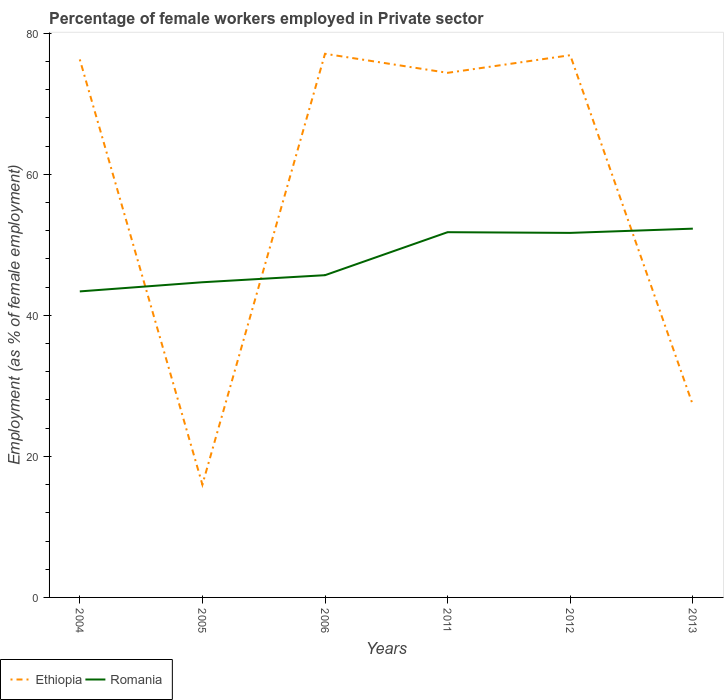Across all years, what is the maximum percentage of females employed in Private sector in Romania?
Your answer should be compact. 43.4. In which year was the percentage of females employed in Private sector in Romania maximum?
Provide a succinct answer. 2004. What is the total percentage of females employed in Private sector in Romania in the graph?
Your answer should be compact. 0.1. What is the difference between the highest and the second highest percentage of females employed in Private sector in Ethiopia?
Your answer should be very brief. 61.1. How many lines are there?
Make the answer very short. 2. What is the difference between two consecutive major ticks on the Y-axis?
Give a very brief answer. 20. What is the title of the graph?
Offer a terse response. Percentage of female workers employed in Private sector. What is the label or title of the X-axis?
Provide a short and direct response. Years. What is the label or title of the Y-axis?
Keep it short and to the point. Employment (as % of female employment). What is the Employment (as % of female employment) of Ethiopia in 2004?
Ensure brevity in your answer.  76.3. What is the Employment (as % of female employment) in Romania in 2004?
Keep it short and to the point. 43.4. What is the Employment (as % of female employment) in Ethiopia in 2005?
Offer a terse response. 16. What is the Employment (as % of female employment) of Romania in 2005?
Your answer should be compact. 44.7. What is the Employment (as % of female employment) in Ethiopia in 2006?
Make the answer very short. 77.1. What is the Employment (as % of female employment) in Romania in 2006?
Ensure brevity in your answer.  45.7. What is the Employment (as % of female employment) in Ethiopia in 2011?
Make the answer very short. 74.4. What is the Employment (as % of female employment) in Romania in 2011?
Provide a short and direct response. 51.8. What is the Employment (as % of female employment) in Ethiopia in 2012?
Ensure brevity in your answer.  76.9. What is the Employment (as % of female employment) in Romania in 2012?
Provide a succinct answer. 51.7. What is the Employment (as % of female employment) in Ethiopia in 2013?
Provide a short and direct response. 27.3. What is the Employment (as % of female employment) of Romania in 2013?
Offer a terse response. 52.3. Across all years, what is the maximum Employment (as % of female employment) of Ethiopia?
Your answer should be compact. 77.1. Across all years, what is the maximum Employment (as % of female employment) of Romania?
Your response must be concise. 52.3. Across all years, what is the minimum Employment (as % of female employment) in Ethiopia?
Give a very brief answer. 16. Across all years, what is the minimum Employment (as % of female employment) in Romania?
Your answer should be compact. 43.4. What is the total Employment (as % of female employment) of Ethiopia in the graph?
Provide a succinct answer. 348. What is the total Employment (as % of female employment) in Romania in the graph?
Your response must be concise. 289.6. What is the difference between the Employment (as % of female employment) in Ethiopia in 2004 and that in 2005?
Your answer should be very brief. 60.3. What is the difference between the Employment (as % of female employment) of Romania in 2004 and that in 2005?
Provide a short and direct response. -1.3. What is the difference between the Employment (as % of female employment) of Ethiopia in 2004 and that in 2006?
Ensure brevity in your answer.  -0.8. What is the difference between the Employment (as % of female employment) of Romania in 2004 and that in 2011?
Keep it short and to the point. -8.4. What is the difference between the Employment (as % of female employment) of Ethiopia in 2004 and that in 2013?
Offer a very short reply. 49. What is the difference between the Employment (as % of female employment) in Romania in 2004 and that in 2013?
Your response must be concise. -8.9. What is the difference between the Employment (as % of female employment) in Ethiopia in 2005 and that in 2006?
Your response must be concise. -61.1. What is the difference between the Employment (as % of female employment) of Romania in 2005 and that in 2006?
Ensure brevity in your answer.  -1. What is the difference between the Employment (as % of female employment) of Ethiopia in 2005 and that in 2011?
Provide a succinct answer. -58.4. What is the difference between the Employment (as % of female employment) of Ethiopia in 2005 and that in 2012?
Ensure brevity in your answer.  -60.9. What is the difference between the Employment (as % of female employment) of Romania in 2005 and that in 2013?
Ensure brevity in your answer.  -7.6. What is the difference between the Employment (as % of female employment) in Ethiopia in 2006 and that in 2011?
Provide a succinct answer. 2.7. What is the difference between the Employment (as % of female employment) in Romania in 2006 and that in 2011?
Make the answer very short. -6.1. What is the difference between the Employment (as % of female employment) of Romania in 2006 and that in 2012?
Make the answer very short. -6. What is the difference between the Employment (as % of female employment) of Ethiopia in 2006 and that in 2013?
Give a very brief answer. 49.8. What is the difference between the Employment (as % of female employment) in Ethiopia in 2011 and that in 2013?
Offer a very short reply. 47.1. What is the difference between the Employment (as % of female employment) of Ethiopia in 2012 and that in 2013?
Keep it short and to the point. 49.6. What is the difference between the Employment (as % of female employment) in Romania in 2012 and that in 2013?
Your answer should be very brief. -0.6. What is the difference between the Employment (as % of female employment) in Ethiopia in 2004 and the Employment (as % of female employment) in Romania in 2005?
Offer a terse response. 31.6. What is the difference between the Employment (as % of female employment) of Ethiopia in 2004 and the Employment (as % of female employment) of Romania in 2006?
Your answer should be very brief. 30.6. What is the difference between the Employment (as % of female employment) of Ethiopia in 2004 and the Employment (as % of female employment) of Romania in 2012?
Your answer should be compact. 24.6. What is the difference between the Employment (as % of female employment) in Ethiopia in 2004 and the Employment (as % of female employment) in Romania in 2013?
Offer a very short reply. 24. What is the difference between the Employment (as % of female employment) in Ethiopia in 2005 and the Employment (as % of female employment) in Romania in 2006?
Make the answer very short. -29.7. What is the difference between the Employment (as % of female employment) in Ethiopia in 2005 and the Employment (as % of female employment) in Romania in 2011?
Ensure brevity in your answer.  -35.8. What is the difference between the Employment (as % of female employment) of Ethiopia in 2005 and the Employment (as % of female employment) of Romania in 2012?
Your response must be concise. -35.7. What is the difference between the Employment (as % of female employment) of Ethiopia in 2005 and the Employment (as % of female employment) of Romania in 2013?
Give a very brief answer. -36.3. What is the difference between the Employment (as % of female employment) in Ethiopia in 2006 and the Employment (as % of female employment) in Romania in 2011?
Offer a terse response. 25.3. What is the difference between the Employment (as % of female employment) of Ethiopia in 2006 and the Employment (as % of female employment) of Romania in 2012?
Your answer should be very brief. 25.4. What is the difference between the Employment (as % of female employment) in Ethiopia in 2006 and the Employment (as % of female employment) in Romania in 2013?
Ensure brevity in your answer.  24.8. What is the difference between the Employment (as % of female employment) in Ethiopia in 2011 and the Employment (as % of female employment) in Romania in 2012?
Provide a short and direct response. 22.7. What is the difference between the Employment (as % of female employment) in Ethiopia in 2011 and the Employment (as % of female employment) in Romania in 2013?
Offer a terse response. 22.1. What is the difference between the Employment (as % of female employment) of Ethiopia in 2012 and the Employment (as % of female employment) of Romania in 2013?
Offer a terse response. 24.6. What is the average Employment (as % of female employment) of Romania per year?
Your answer should be compact. 48.27. In the year 2004, what is the difference between the Employment (as % of female employment) in Ethiopia and Employment (as % of female employment) in Romania?
Your response must be concise. 32.9. In the year 2005, what is the difference between the Employment (as % of female employment) of Ethiopia and Employment (as % of female employment) of Romania?
Keep it short and to the point. -28.7. In the year 2006, what is the difference between the Employment (as % of female employment) of Ethiopia and Employment (as % of female employment) of Romania?
Your response must be concise. 31.4. In the year 2011, what is the difference between the Employment (as % of female employment) of Ethiopia and Employment (as % of female employment) of Romania?
Ensure brevity in your answer.  22.6. In the year 2012, what is the difference between the Employment (as % of female employment) in Ethiopia and Employment (as % of female employment) in Romania?
Provide a succinct answer. 25.2. What is the ratio of the Employment (as % of female employment) of Ethiopia in 2004 to that in 2005?
Keep it short and to the point. 4.77. What is the ratio of the Employment (as % of female employment) in Romania in 2004 to that in 2005?
Offer a very short reply. 0.97. What is the ratio of the Employment (as % of female employment) of Romania in 2004 to that in 2006?
Keep it short and to the point. 0.95. What is the ratio of the Employment (as % of female employment) of Ethiopia in 2004 to that in 2011?
Offer a terse response. 1.03. What is the ratio of the Employment (as % of female employment) of Romania in 2004 to that in 2011?
Your answer should be very brief. 0.84. What is the ratio of the Employment (as % of female employment) in Ethiopia in 2004 to that in 2012?
Provide a short and direct response. 0.99. What is the ratio of the Employment (as % of female employment) of Romania in 2004 to that in 2012?
Keep it short and to the point. 0.84. What is the ratio of the Employment (as % of female employment) in Ethiopia in 2004 to that in 2013?
Ensure brevity in your answer.  2.79. What is the ratio of the Employment (as % of female employment) of Romania in 2004 to that in 2013?
Offer a very short reply. 0.83. What is the ratio of the Employment (as % of female employment) in Ethiopia in 2005 to that in 2006?
Offer a terse response. 0.21. What is the ratio of the Employment (as % of female employment) of Romania in 2005 to that in 2006?
Ensure brevity in your answer.  0.98. What is the ratio of the Employment (as % of female employment) of Ethiopia in 2005 to that in 2011?
Offer a terse response. 0.22. What is the ratio of the Employment (as % of female employment) in Romania in 2005 to that in 2011?
Your response must be concise. 0.86. What is the ratio of the Employment (as % of female employment) of Ethiopia in 2005 to that in 2012?
Provide a short and direct response. 0.21. What is the ratio of the Employment (as % of female employment) in Romania in 2005 to that in 2012?
Offer a terse response. 0.86. What is the ratio of the Employment (as % of female employment) of Ethiopia in 2005 to that in 2013?
Provide a short and direct response. 0.59. What is the ratio of the Employment (as % of female employment) of Romania in 2005 to that in 2013?
Provide a succinct answer. 0.85. What is the ratio of the Employment (as % of female employment) of Ethiopia in 2006 to that in 2011?
Your answer should be compact. 1.04. What is the ratio of the Employment (as % of female employment) in Romania in 2006 to that in 2011?
Offer a very short reply. 0.88. What is the ratio of the Employment (as % of female employment) in Ethiopia in 2006 to that in 2012?
Your answer should be compact. 1. What is the ratio of the Employment (as % of female employment) in Romania in 2006 to that in 2012?
Provide a short and direct response. 0.88. What is the ratio of the Employment (as % of female employment) of Ethiopia in 2006 to that in 2013?
Keep it short and to the point. 2.82. What is the ratio of the Employment (as % of female employment) of Romania in 2006 to that in 2013?
Your answer should be compact. 0.87. What is the ratio of the Employment (as % of female employment) in Ethiopia in 2011 to that in 2012?
Ensure brevity in your answer.  0.97. What is the ratio of the Employment (as % of female employment) of Romania in 2011 to that in 2012?
Keep it short and to the point. 1. What is the ratio of the Employment (as % of female employment) of Ethiopia in 2011 to that in 2013?
Your answer should be compact. 2.73. What is the ratio of the Employment (as % of female employment) in Romania in 2011 to that in 2013?
Your answer should be compact. 0.99. What is the ratio of the Employment (as % of female employment) in Ethiopia in 2012 to that in 2013?
Make the answer very short. 2.82. What is the difference between the highest and the second highest Employment (as % of female employment) in Ethiopia?
Ensure brevity in your answer.  0.2. What is the difference between the highest and the second highest Employment (as % of female employment) of Romania?
Keep it short and to the point. 0.5. What is the difference between the highest and the lowest Employment (as % of female employment) of Ethiopia?
Provide a short and direct response. 61.1. 